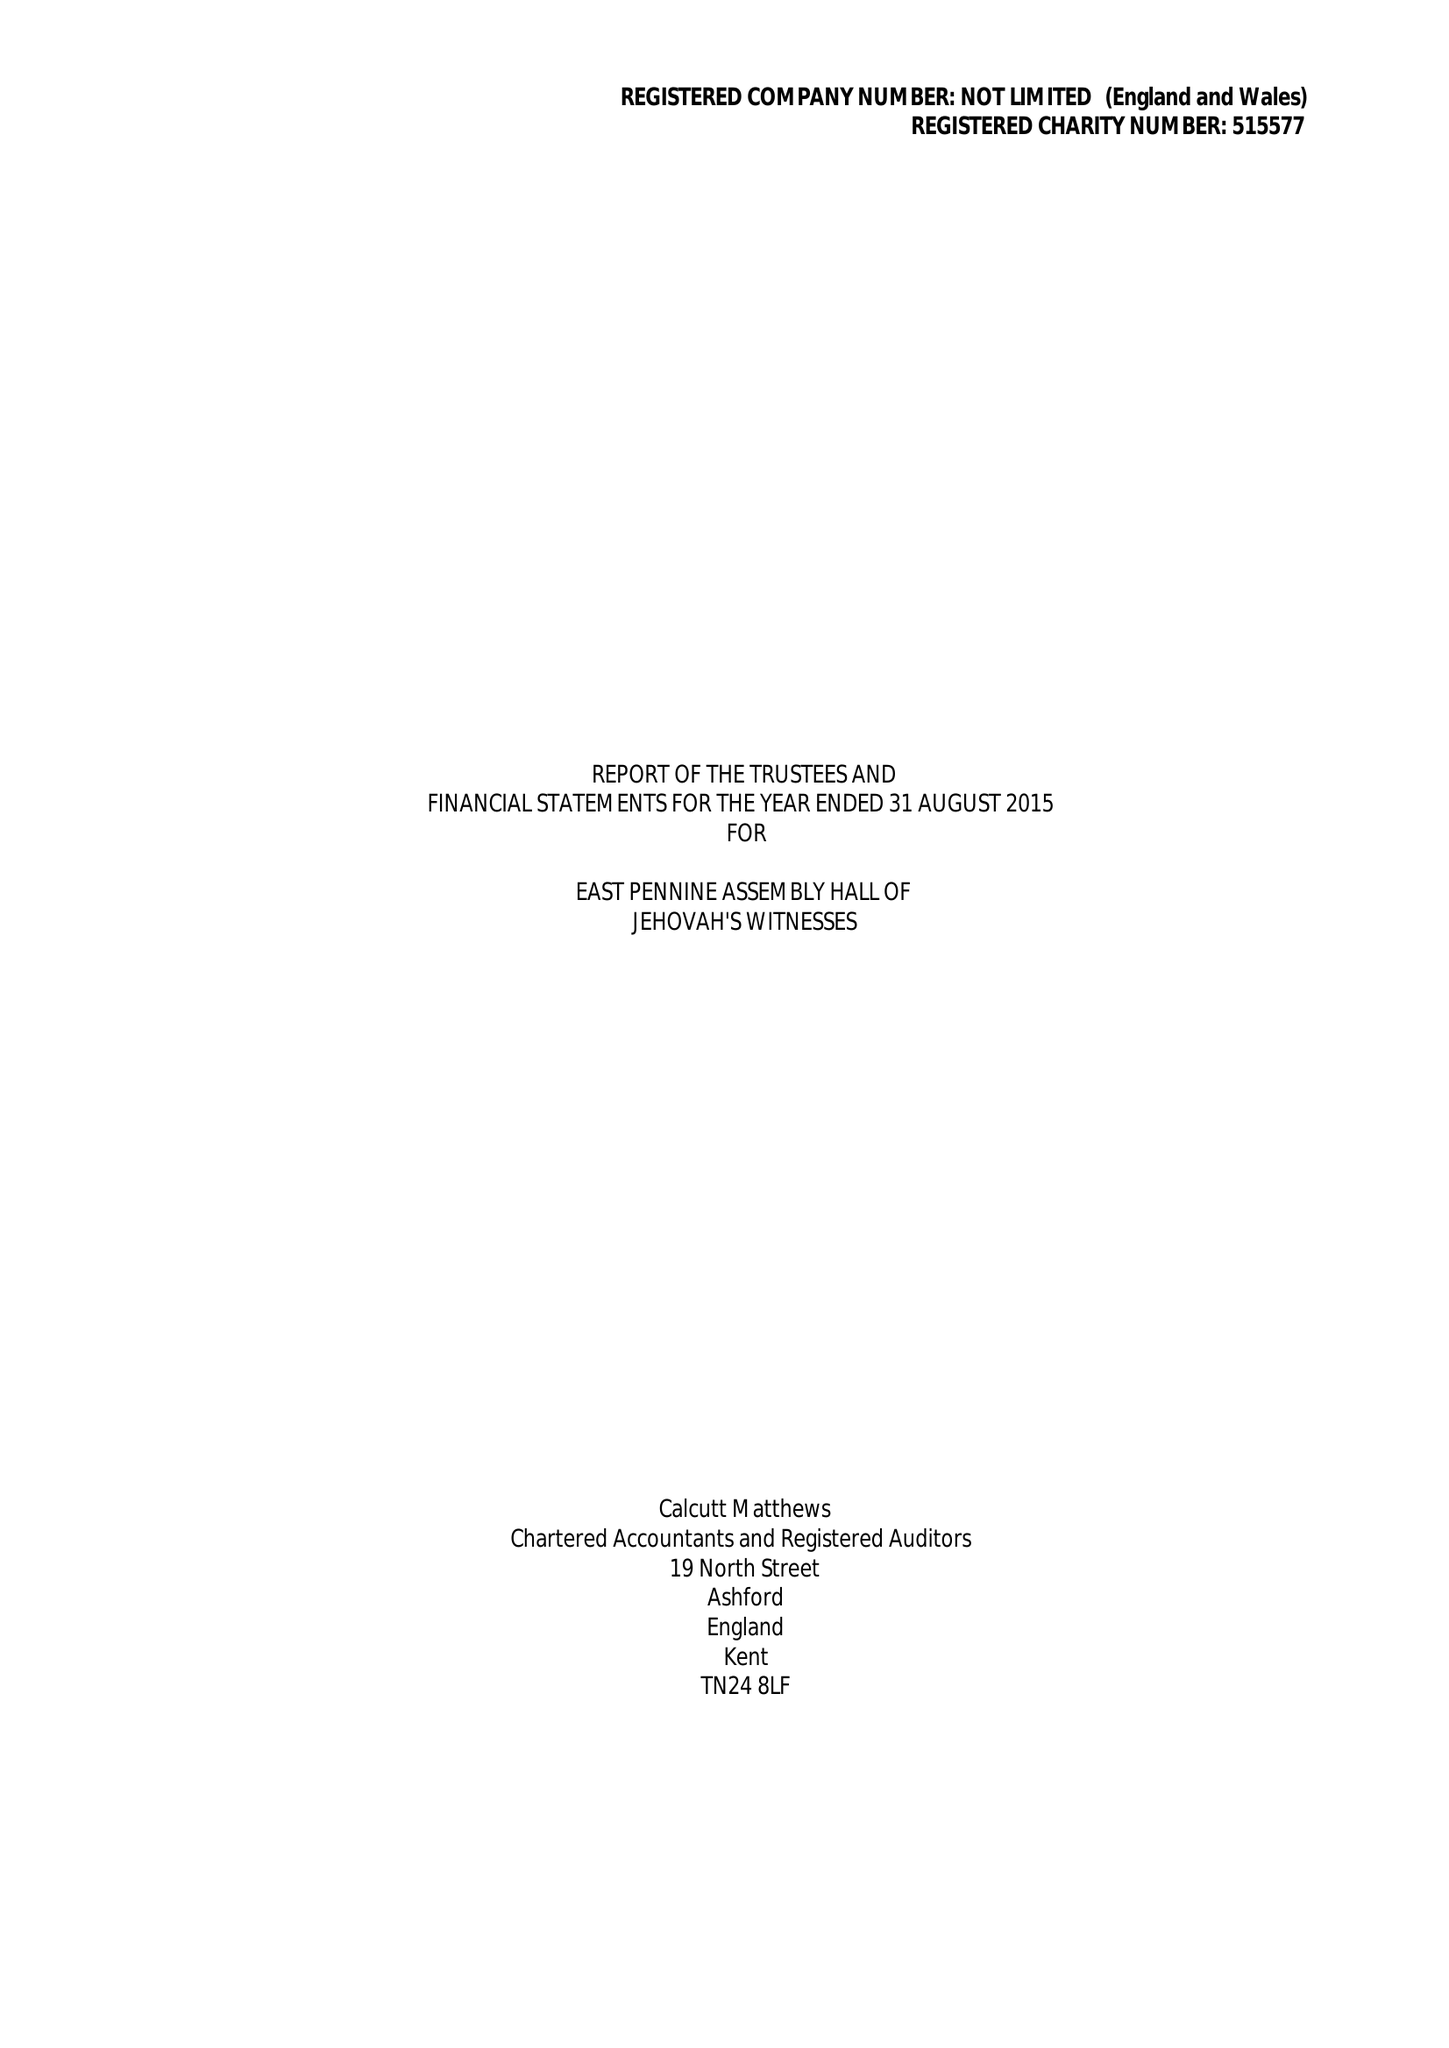What is the value for the spending_annually_in_british_pounds?
Answer the question using a single word or phrase. 517046.00 